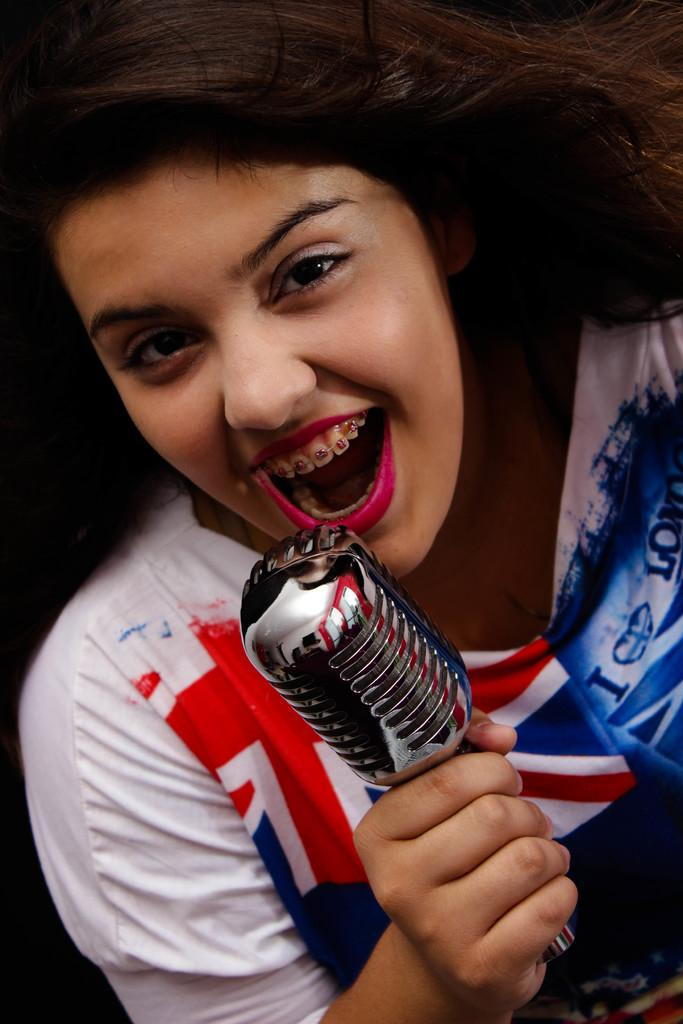Who is the main subject in the image? There is a woman in the image. What is the woman holding in the image? The woman is holding a microphone. What might the woman be doing based on her mouth position? The woman's mouth position suggests she might be singing. What type of robin can be seen on the woman's skin in the image? There is no robin present on the woman's skin in the image. 